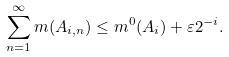<formula> <loc_0><loc_0><loc_500><loc_500>\sum _ { n = 1 } ^ { \infty } m ( A _ { i , n } ) \leq m ^ { 0 } ( A _ { i } ) + \varepsilon 2 ^ { - i } .</formula> 